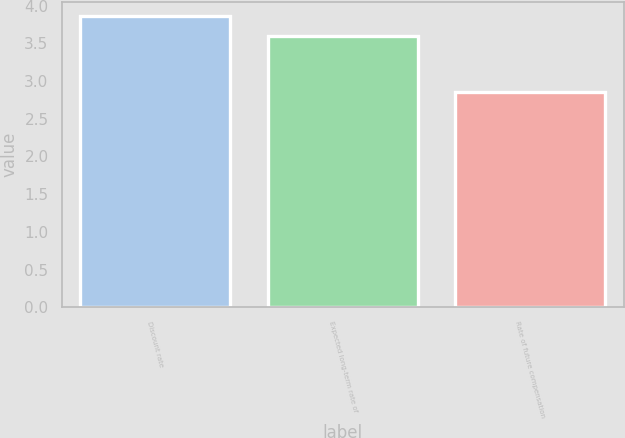<chart> <loc_0><loc_0><loc_500><loc_500><bar_chart><fcel>Discount rate<fcel>Expected long-term rate of<fcel>Rate of future compensation<nl><fcel>3.86<fcel>3.59<fcel>2.85<nl></chart> 